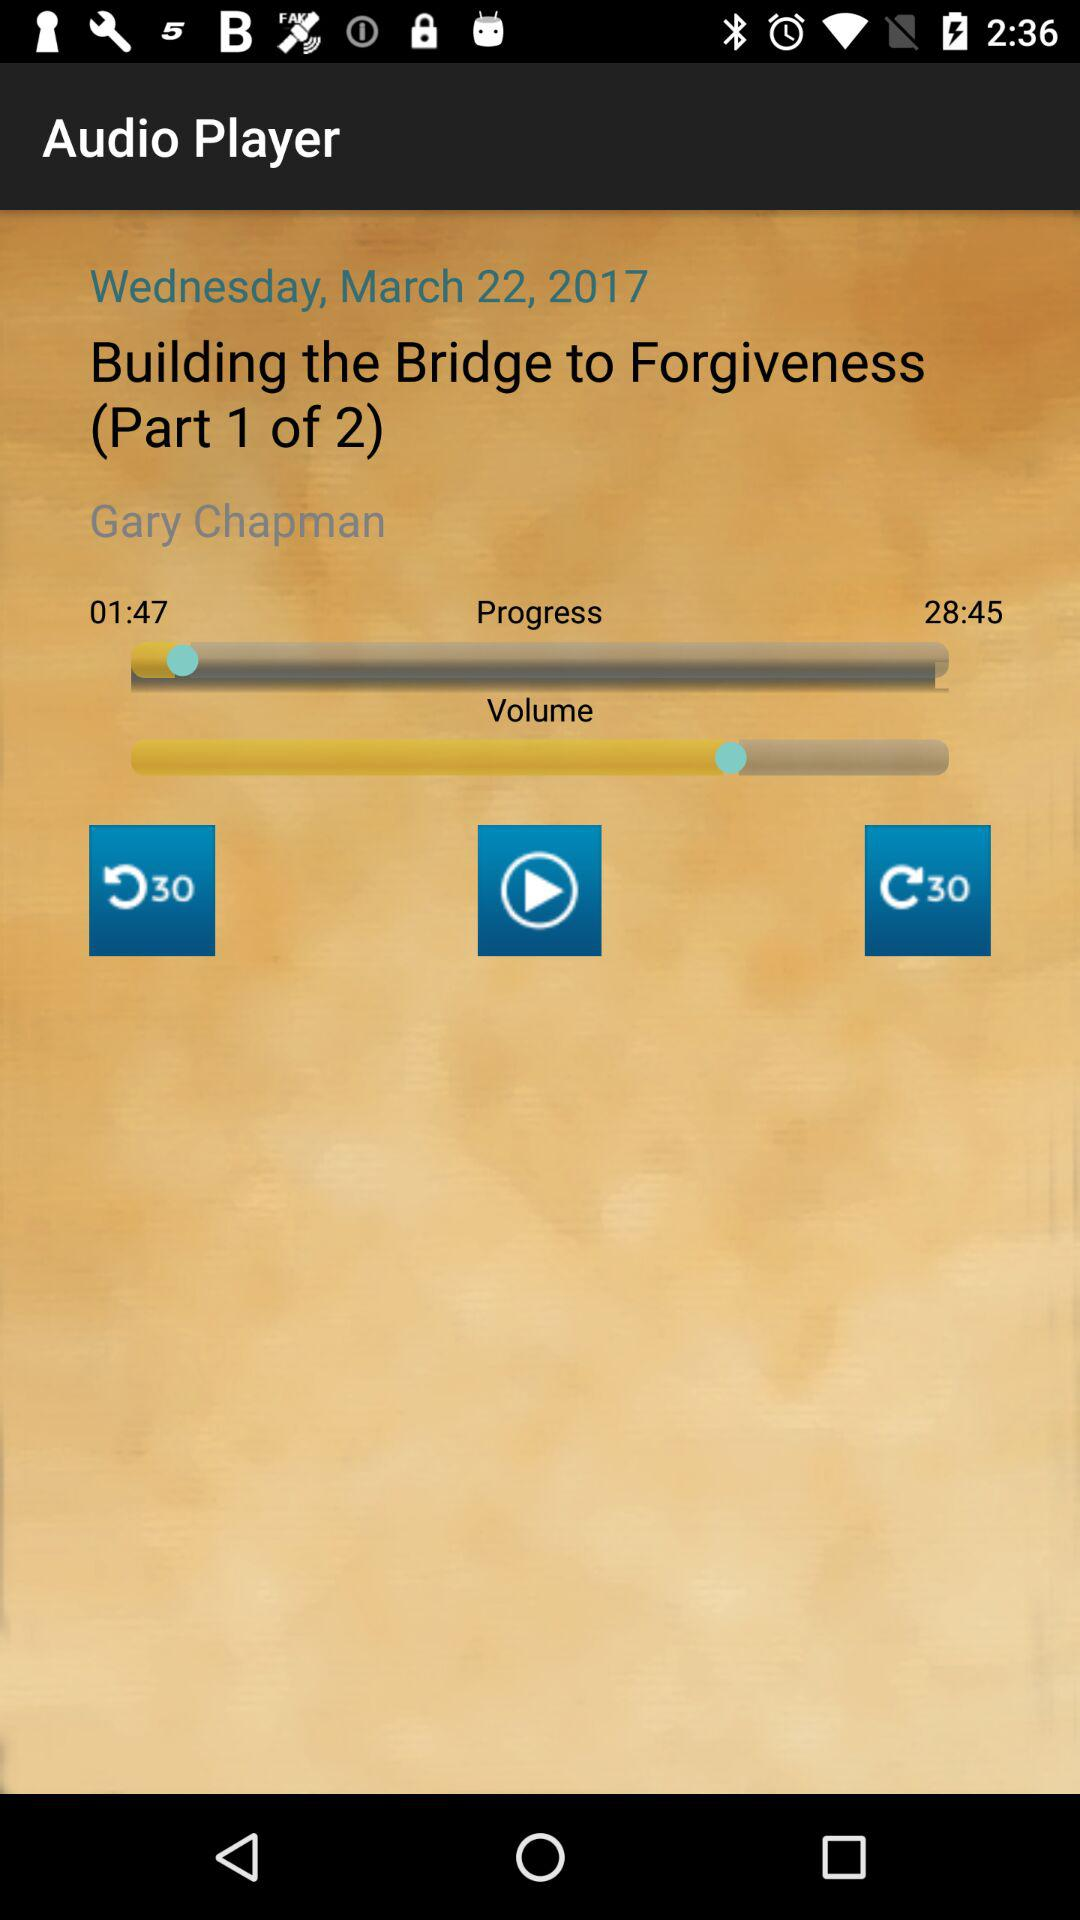For which date is the audio player shown? The date is Wednesday, March 22, 2017. 